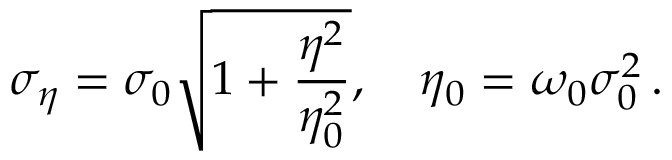<formula> <loc_0><loc_0><loc_500><loc_500>\sigma _ { \eta } = \sigma _ { 0 } \sqrt { 1 + \frac { \eta ^ { 2 } } { \eta _ { 0 } ^ { 2 } } } , \quad \eta _ { 0 } = \omega _ { 0 } \sigma _ { 0 } ^ { 2 } \, .</formula> 